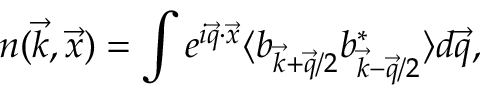<formula> <loc_0><loc_0><loc_500><loc_500>n ( \vec { k } , \vec { x } ) = \int e ^ { i \vec { q } \cdot \vec { x } } \langle b _ { \vec { k } + \vec { q } / 2 } b _ { \vec { k } - \vec { q } / 2 } ^ { * } \rangle d \vec { q } ,</formula> 